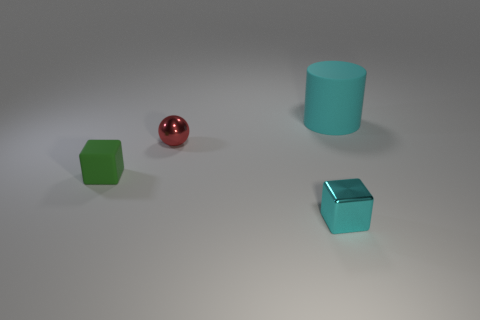What might the spatial arrangement of these objects represent? The spatial arrangement in the image could represent a sense of balance and simplicity. Each object is placed equidistant from the others, with no overlap, creating a harmonious and orderly composition that is pleasing to the eye. This could be interpreted as a minimalist approach to design, prioritizing space and form. 